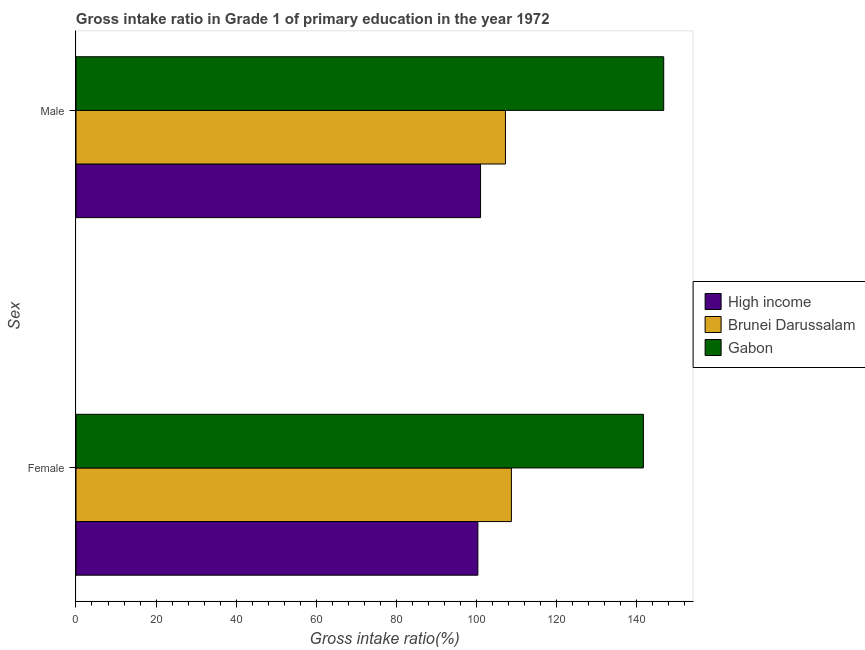Are the number of bars per tick equal to the number of legend labels?
Provide a short and direct response. Yes. Are the number of bars on each tick of the Y-axis equal?
Your answer should be very brief. Yes. How many bars are there on the 1st tick from the top?
Your response must be concise. 3. What is the gross intake ratio(female) in High income?
Your answer should be very brief. 100.46. Across all countries, what is the maximum gross intake ratio(male)?
Make the answer very short. 146.92. Across all countries, what is the minimum gross intake ratio(female)?
Ensure brevity in your answer.  100.46. In which country was the gross intake ratio(female) maximum?
Keep it short and to the point. Gabon. In which country was the gross intake ratio(male) minimum?
Provide a succinct answer. High income. What is the total gross intake ratio(female) in the graph?
Your answer should be very brief. 351.14. What is the difference between the gross intake ratio(male) in Brunei Darussalam and that in Gabon?
Your answer should be compact. -39.56. What is the difference between the gross intake ratio(male) in Gabon and the gross intake ratio(female) in High income?
Your answer should be compact. 46.46. What is the average gross intake ratio(female) per country?
Ensure brevity in your answer.  117.05. What is the difference between the gross intake ratio(male) and gross intake ratio(female) in Gabon?
Keep it short and to the point. 5.08. What is the ratio of the gross intake ratio(male) in Gabon to that in Brunei Darussalam?
Make the answer very short. 1.37. Is the gross intake ratio(female) in High income less than that in Gabon?
Offer a terse response. Yes. In how many countries, is the gross intake ratio(female) greater than the average gross intake ratio(female) taken over all countries?
Your answer should be compact. 1. What does the 1st bar from the top in Male represents?
Keep it short and to the point. Gabon. What does the 3rd bar from the bottom in Female represents?
Give a very brief answer. Gabon. How many bars are there?
Your answer should be very brief. 6. What is the difference between two consecutive major ticks on the X-axis?
Offer a very short reply. 20. Does the graph contain any zero values?
Your answer should be compact. No. How are the legend labels stacked?
Ensure brevity in your answer.  Vertical. What is the title of the graph?
Offer a terse response. Gross intake ratio in Grade 1 of primary education in the year 1972. Does "Middle East & North Africa (developing only)" appear as one of the legend labels in the graph?
Ensure brevity in your answer.  No. What is the label or title of the X-axis?
Provide a succinct answer. Gross intake ratio(%). What is the label or title of the Y-axis?
Make the answer very short. Sex. What is the Gross intake ratio(%) in High income in Female?
Keep it short and to the point. 100.46. What is the Gross intake ratio(%) of Brunei Darussalam in Female?
Keep it short and to the point. 108.84. What is the Gross intake ratio(%) in Gabon in Female?
Keep it short and to the point. 141.84. What is the Gross intake ratio(%) in High income in Male?
Offer a terse response. 101.13. What is the Gross intake ratio(%) of Brunei Darussalam in Male?
Keep it short and to the point. 107.36. What is the Gross intake ratio(%) of Gabon in Male?
Give a very brief answer. 146.92. Across all Sex, what is the maximum Gross intake ratio(%) in High income?
Provide a short and direct response. 101.13. Across all Sex, what is the maximum Gross intake ratio(%) of Brunei Darussalam?
Make the answer very short. 108.84. Across all Sex, what is the maximum Gross intake ratio(%) in Gabon?
Your answer should be compact. 146.92. Across all Sex, what is the minimum Gross intake ratio(%) in High income?
Keep it short and to the point. 100.46. Across all Sex, what is the minimum Gross intake ratio(%) of Brunei Darussalam?
Your response must be concise. 107.36. Across all Sex, what is the minimum Gross intake ratio(%) in Gabon?
Your answer should be compact. 141.84. What is the total Gross intake ratio(%) in High income in the graph?
Provide a succinct answer. 201.59. What is the total Gross intake ratio(%) in Brunei Darussalam in the graph?
Provide a short and direct response. 216.2. What is the total Gross intake ratio(%) of Gabon in the graph?
Your answer should be very brief. 288.76. What is the difference between the Gross intake ratio(%) in High income in Female and that in Male?
Your response must be concise. -0.67. What is the difference between the Gross intake ratio(%) in Brunei Darussalam in Female and that in Male?
Offer a terse response. 1.48. What is the difference between the Gross intake ratio(%) in Gabon in Female and that in Male?
Provide a short and direct response. -5.08. What is the difference between the Gross intake ratio(%) of High income in Female and the Gross intake ratio(%) of Brunei Darussalam in Male?
Provide a short and direct response. -6.9. What is the difference between the Gross intake ratio(%) in High income in Female and the Gross intake ratio(%) in Gabon in Male?
Your response must be concise. -46.46. What is the difference between the Gross intake ratio(%) in Brunei Darussalam in Female and the Gross intake ratio(%) in Gabon in Male?
Your answer should be compact. -38.08. What is the average Gross intake ratio(%) of High income per Sex?
Your answer should be very brief. 100.79. What is the average Gross intake ratio(%) of Brunei Darussalam per Sex?
Your answer should be compact. 108.1. What is the average Gross intake ratio(%) of Gabon per Sex?
Keep it short and to the point. 144.38. What is the difference between the Gross intake ratio(%) of High income and Gross intake ratio(%) of Brunei Darussalam in Female?
Your response must be concise. -8.38. What is the difference between the Gross intake ratio(%) of High income and Gross intake ratio(%) of Gabon in Female?
Your response must be concise. -41.38. What is the difference between the Gross intake ratio(%) in Brunei Darussalam and Gross intake ratio(%) in Gabon in Female?
Offer a terse response. -33. What is the difference between the Gross intake ratio(%) in High income and Gross intake ratio(%) in Brunei Darussalam in Male?
Give a very brief answer. -6.23. What is the difference between the Gross intake ratio(%) in High income and Gross intake ratio(%) in Gabon in Male?
Make the answer very short. -45.79. What is the difference between the Gross intake ratio(%) in Brunei Darussalam and Gross intake ratio(%) in Gabon in Male?
Your answer should be compact. -39.56. What is the ratio of the Gross intake ratio(%) of Brunei Darussalam in Female to that in Male?
Keep it short and to the point. 1.01. What is the ratio of the Gross intake ratio(%) in Gabon in Female to that in Male?
Make the answer very short. 0.97. What is the difference between the highest and the second highest Gross intake ratio(%) in High income?
Keep it short and to the point. 0.67. What is the difference between the highest and the second highest Gross intake ratio(%) of Brunei Darussalam?
Provide a succinct answer. 1.48. What is the difference between the highest and the second highest Gross intake ratio(%) of Gabon?
Provide a short and direct response. 5.08. What is the difference between the highest and the lowest Gross intake ratio(%) in High income?
Ensure brevity in your answer.  0.67. What is the difference between the highest and the lowest Gross intake ratio(%) of Brunei Darussalam?
Ensure brevity in your answer.  1.48. What is the difference between the highest and the lowest Gross intake ratio(%) of Gabon?
Keep it short and to the point. 5.08. 